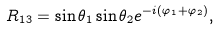<formula> <loc_0><loc_0><loc_500><loc_500>R _ { 1 3 } = \sin \theta _ { 1 } \sin \theta _ { 2 } e ^ { - i ( \varphi _ { 1 } + \varphi _ { 2 } ) } ,</formula> 